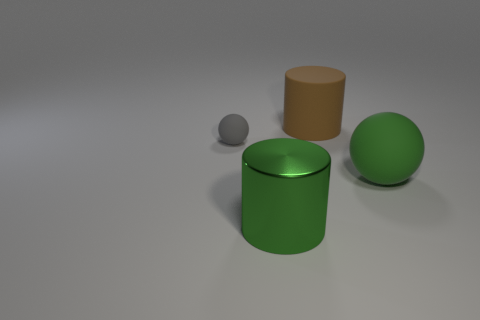Compared to the other objects, how would you describe the position of the green sphere? The green sphere is positioned to the right of the composition, standing out due to its size and vibrant color. Its placement creates a balance by contrasting with the smaller, more subdued-colored objects to the left. 